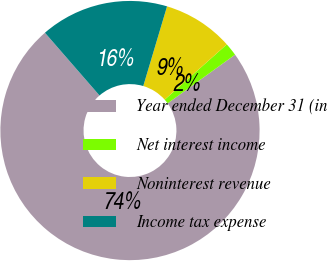Convert chart to OTSL. <chart><loc_0><loc_0><loc_500><loc_500><pie_chart><fcel>Year ended December 31 (in<fcel>Net interest income<fcel>Noninterest revenue<fcel>Income tax expense<nl><fcel>73.57%<fcel>1.62%<fcel>8.81%<fcel>16.01%<nl></chart> 